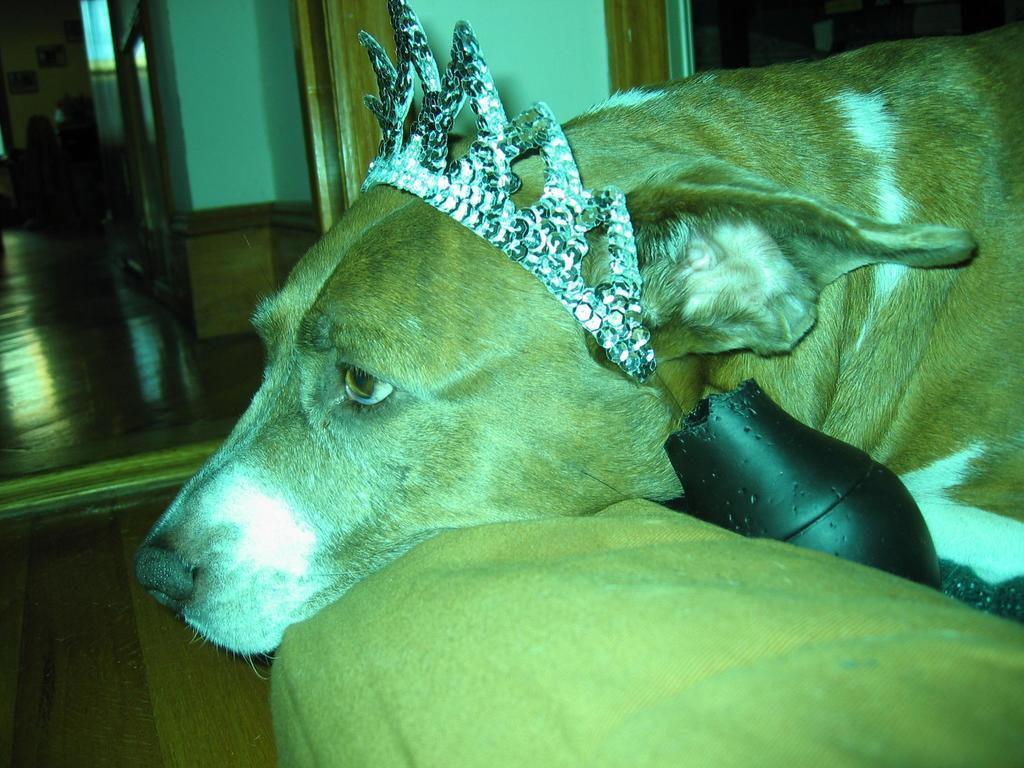What animal can be seen on the right side of the image? There is a dog on the right side of the image. What is present on the wall in the background of the image? There are photo frames on the wall in the background of the image. What type of robin can be seen perched on the dog's head in the image? There is no robin present in the image; it only features a dog and photo frames on the wall. 